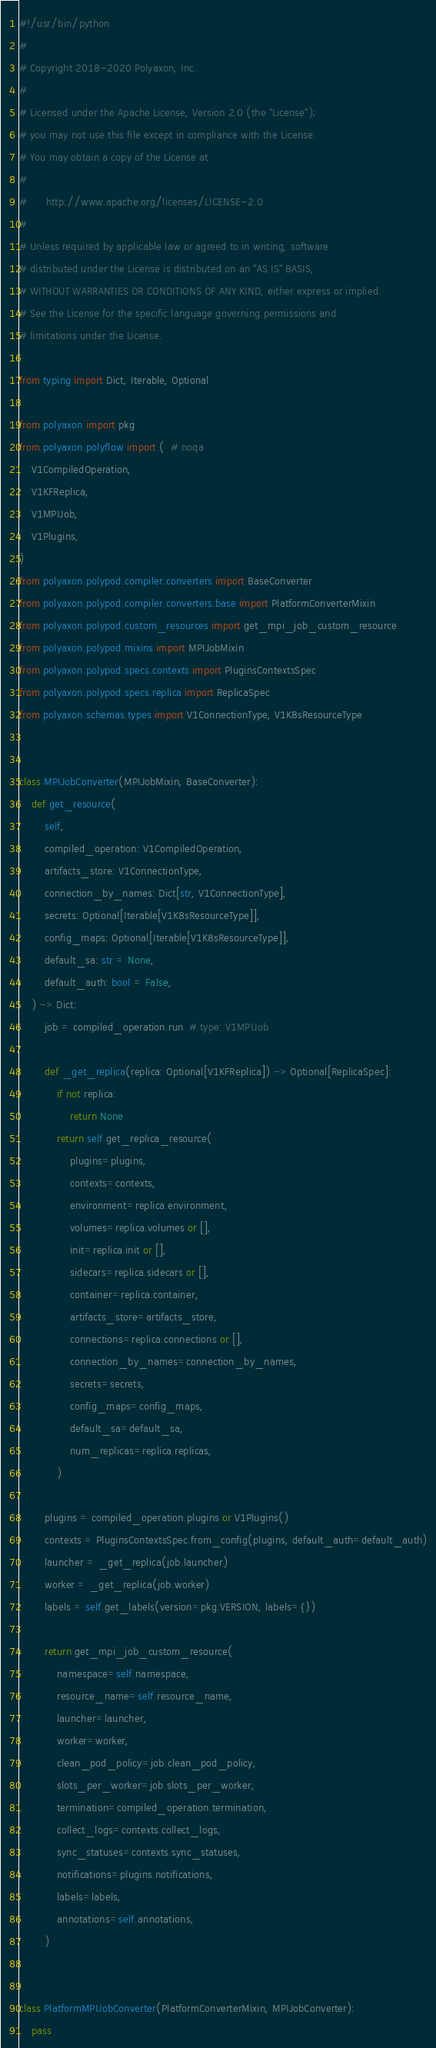Convert code to text. <code><loc_0><loc_0><loc_500><loc_500><_Python_>#!/usr/bin/python
#
# Copyright 2018-2020 Polyaxon, Inc.
#
# Licensed under the Apache License, Version 2.0 (the "License");
# you may not use this file except in compliance with the License.
# You may obtain a copy of the License at
#
#      http://www.apache.org/licenses/LICENSE-2.0
#
# Unless required by applicable law or agreed to in writing, software
# distributed under the License is distributed on an "AS IS" BASIS,
# WITHOUT WARRANTIES OR CONDITIONS OF ANY KIND, either express or implied.
# See the License for the specific language governing permissions and
# limitations under the License.

from typing import Dict, Iterable, Optional

from polyaxon import pkg
from polyaxon.polyflow import (  # noqa
    V1CompiledOperation,
    V1KFReplica,
    V1MPIJob,
    V1Plugins,
)
from polyaxon.polypod.compiler.converters import BaseConverter
from polyaxon.polypod.compiler.converters.base import PlatformConverterMixin
from polyaxon.polypod.custom_resources import get_mpi_job_custom_resource
from polyaxon.polypod.mixins import MPIJobMixin
from polyaxon.polypod.specs.contexts import PluginsContextsSpec
from polyaxon.polypod.specs.replica import ReplicaSpec
from polyaxon.schemas.types import V1ConnectionType, V1K8sResourceType


class MPIJobConverter(MPIJobMixin, BaseConverter):
    def get_resource(
        self,
        compiled_operation: V1CompiledOperation,
        artifacts_store: V1ConnectionType,
        connection_by_names: Dict[str, V1ConnectionType],
        secrets: Optional[Iterable[V1K8sResourceType]],
        config_maps: Optional[Iterable[V1K8sResourceType]],
        default_sa: str = None,
        default_auth: bool = False,
    ) -> Dict:
        job = compiled_operation.run  # type: V1MPIJob

        def _get_replica(replica: Optional[V1KFReplica]) -> Optional[ReplicaSpec]:
            if not replica:
                return None
            return self.get_replica_resource(
                plugins=plugins,
                contexts=contexts,
                environment=replica.environment,
                volumes=replica.volumes or [],
                init=replica.init or [],
                sidecars=replica.sidecars or [],
                container=replica.container,
                artifacts_store=artifacts_store,
                connections=replica.connections or [],
                connection_by_names=connection_by_names,
                secrets=secrets,
                config_maps=config_maps,
                default_sa=default_sa,
                num_replicas=replica.replicas,
            )

        plugins = compiled_operation.plugins or V1Plugins()
        contexts = PluginsContextsSpec.from_config(plugins, default_auth=default_auth)
        launcher = _get_replica(job.launcher)
        worker = _get_replica(job.worker)
        labels = self.get_labels(version=pkg.VERSION, labels={})

        return get_mpi_job_custom_resource(
            namespace=self.namespace,
            resource_name=self.resource_name,
            launcher=launcher,
            worker=worker,
            clean_pod_policy=job.clean_pod_policy,
            slots_per_worker=job.slots_per_worker,
            termination=compiled_operation.termination,
            collect_logs=contexts.collect_logs,
            sync_statuses=contexts.sync_statuses,
            notifications=plugins.notifications,
            labels=labels,
            annotations=self.annotations,
        )


class PlatformMPIJobConverter(PlatformConverterMixin, MPIJobConverter):
    pass
</code> 